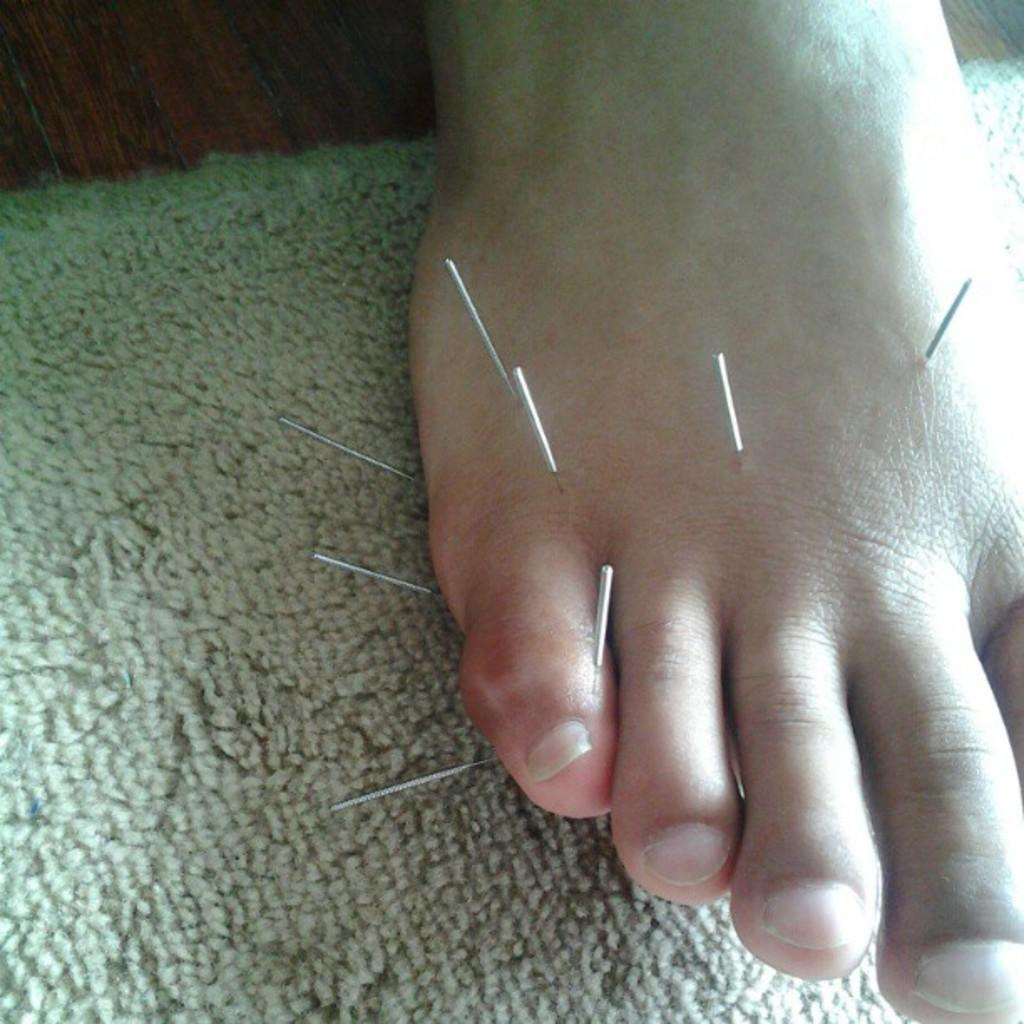What part of the body can be seen in the image? There is a person's leg in the image. What objects are visible in the image besides the leg? There are needles visible in the image. What type of surface is present in the image? There is a mat in cream color in the image. What type of collar is the goat wearing in the image? There is no goat or collar present in the image. 